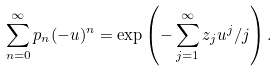Convert formula to latex. <formula><loc_0><loc_0><loc_500><loc_500>\sum _ { n = 0 } ^ { \infty } p _ { n } ( - u ) ^ { n } = \exp \left ( - \sum _ { j = 1 } ^ { \infty } z _ { j } u ^ { j } / j \right ) .</formula> 